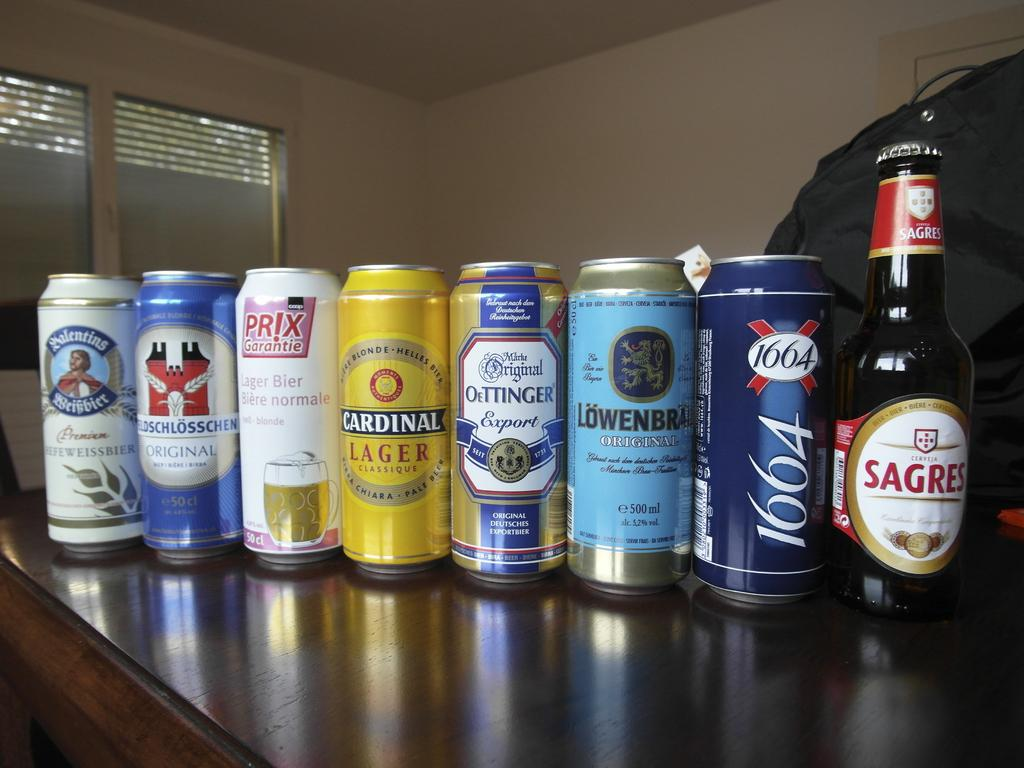<image>
Create a compact narrative representing the image presented. The collection of cans and bottles includes Cardinal Lager. 